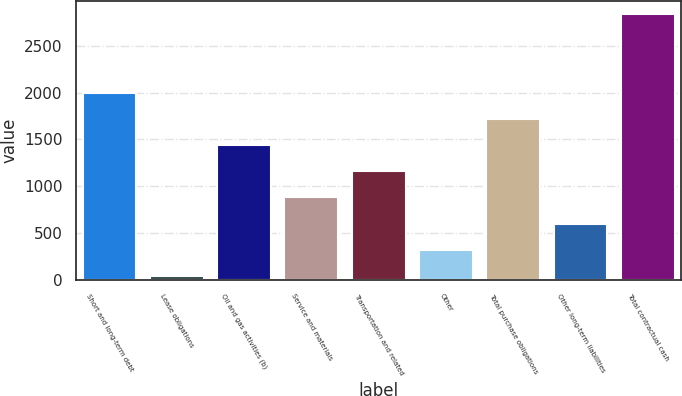Convert chart to OTSL. <chart><loc_0><loc_0><loc_500><loc_500><bar_chart><fcel>Short and long-term debt<fcel>Lease obligations<fcel>Oil and gas activities (b)<fcel>Service and materials<fcel>Transportation and related<fcel>Other<fcel>Total purchase obligations<fcel>Other long-term liabilities<fcel>Total contractual cash<nl><fcel>1999.6<fcel>41<fcel>1440<fcel>880.4<fcel>1160.2<fcel>320.8<fcel>1719.8<fcel>600.6<fcel>2839<nl></chart> 